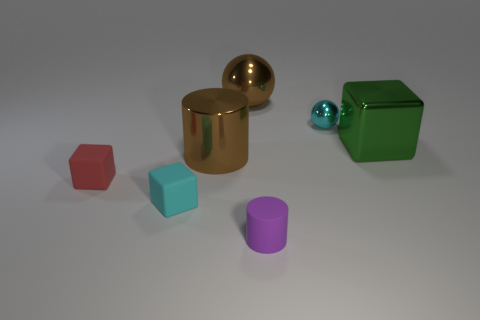Add 3 tiny cyan matte objects. How many objects exist? 10 Subtract all balls. How many objects are left? 5 Add 5 large metallic balls. How many large metallic balls exist? 6 Subtract 0 yellow spheres. How many objects are left? 7 Subtract all big brown cubes. Subtract all brown objects. How many objects are left? 5 Add 6 purple cylinders. How many purple cylinders are left? 7 